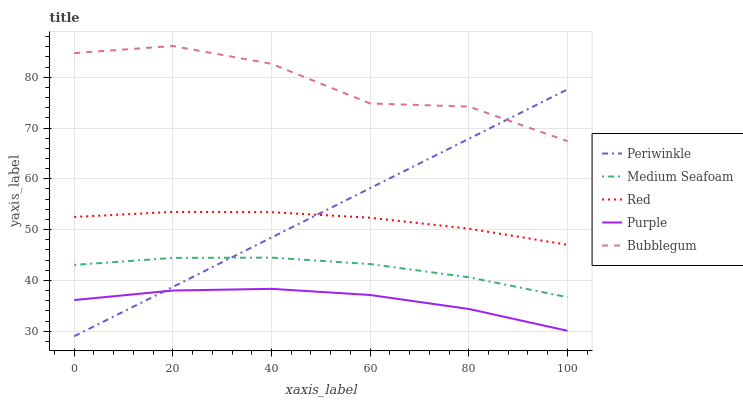Does Purple have the minimum area under the curve?
Answer yes or no. Yes. Does Bubblegum have the maximum area under the curve?
Answer yes or no. Yes. Does Periwinkle have the minimum area under the curve?
Answer yes or no. No. Does Periwinkle have the maximum area under the curve?
Answer yes or no. No. Is Periwinkle the smoothest?
Answer yes or no. Yes. Is Bubblegum the roughest?
Answer yes or no. Yes. Is Bubblegum the smoothest?
Answer yes or no. No. Is Periwinkle the roughest?
Answer yes or no. No. Does Periwinkle have the lowest value?
Answer yes or no. Yes. Does Bubblegum have the lowest value?
Answer yes or no. No. Does Bubblegum have the highest value?
Answer yes or no. Yes. Does Periwinkle have the highest value?
Answer yes or no. No. Is Purple less than Medium Seafoam?
Answer yes or no. Yes. Is Red greater than Medium Seafoam?
Answer yes or no. Yes. Does Red intersect Periwinkle?
Answer yes or no. Yes. Is Red less than Periwinkle?
Answer yes or no. No. Is Red greater than Periwinkle?
Answer yes or no. No. Does Purple intersect Medium Seafoam?
Answer yes or no. No. 